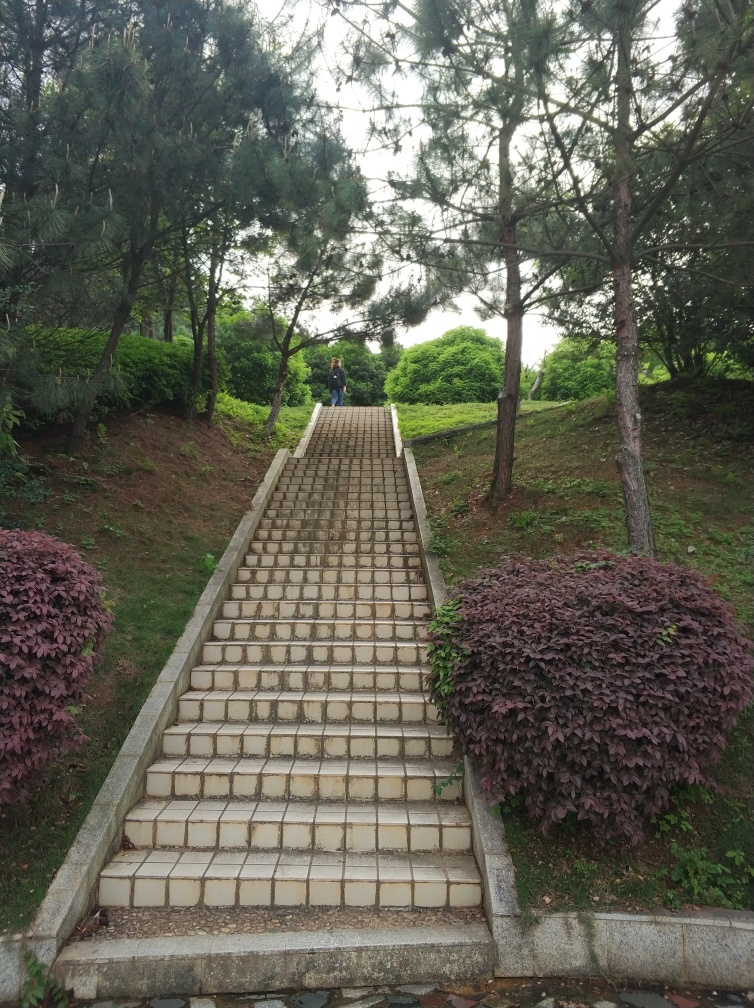What does this scene tell us about the location's maintenance and usage? The scene suggests that the location is well-maintained, given the intact tiles and the organized appearance of the plants on either side of the stairs. The wear on some tiles, however, indicates a fair amount of usage over time. The trimmed bushes and lack of debris also hint at regular upkeep. 